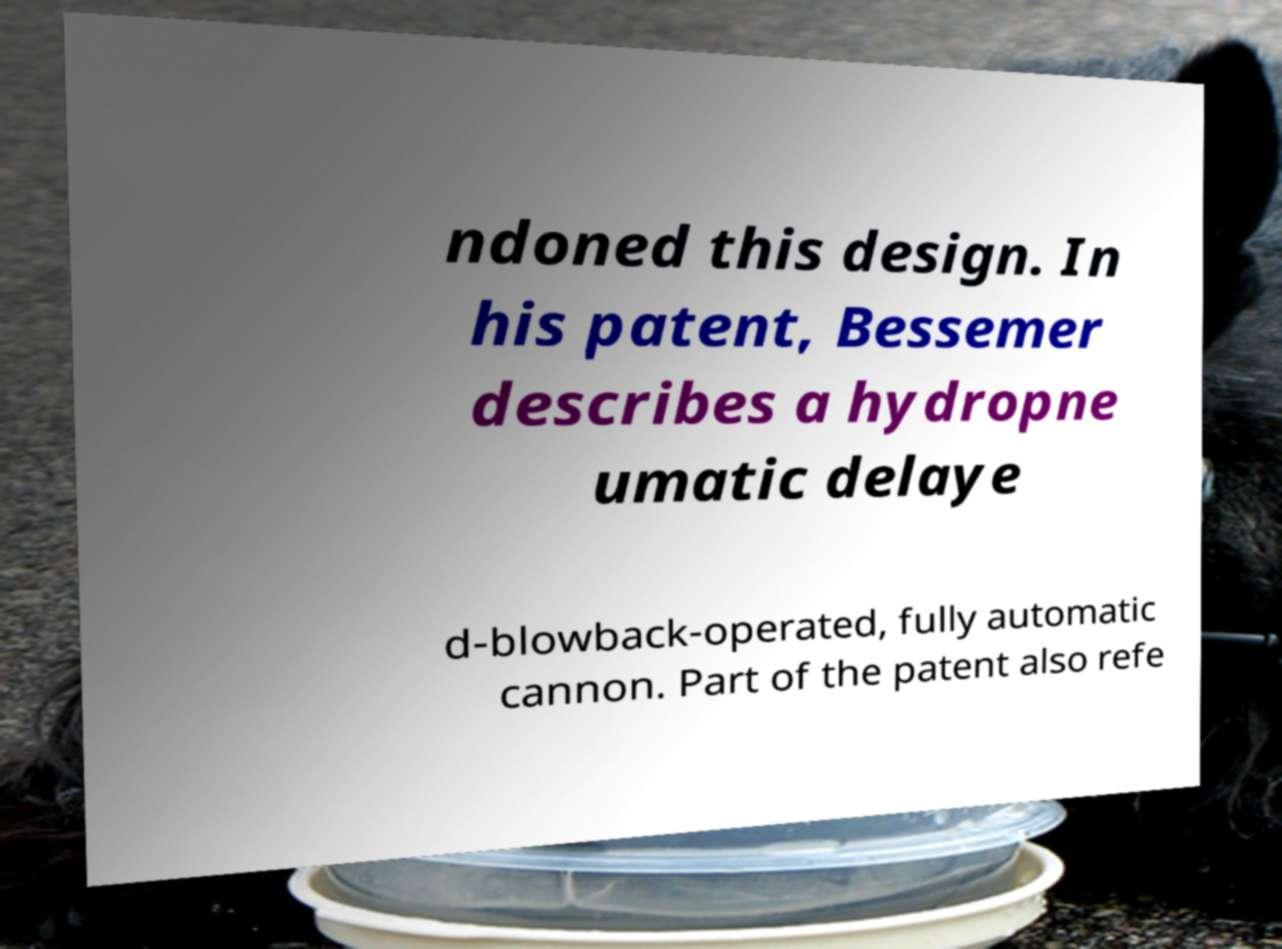I need the written content from this picture converted into text. Can you do that? ndoned this design. In his patent, Bessemer describes a hydropne umatic delaye d-blowback-operated, fully automatic cannon. Part of the patent also refe 